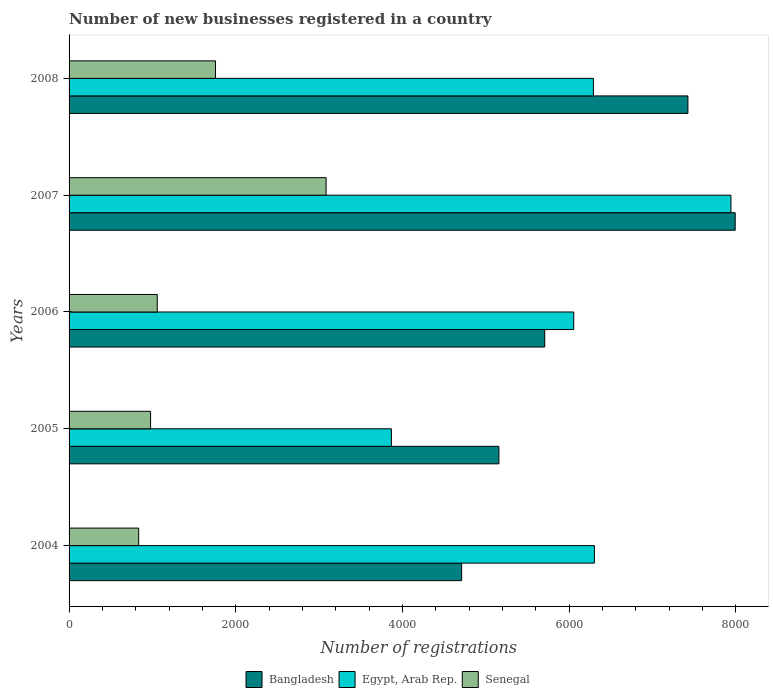How many different coloured bars are there?
Your answer should be very brief. 3. Are the number of bars per tick equal to the number of legend labels?
Ensure brevity in your answer.  Yes. Are the number of bars on each tick of the Y-axis equal?
Provide a short and direct response. Yes. How many bars are there on the 4th tick from the top?
Your answer should be very brief. 3. What is the label of the 4th group of bars from the top?
Provide a succinct answer. 2005. What is the number of new businesses registered in Senegal in 2006?
Your answer should be compact. 1058. Across all years, what is the maximum number of new businesses registered in Senegal?
Give a very brief answer. 3084. Across all years, what is the minimum number of new businesses registered in Senegal?
Your answer should be compact. 835. In which year was the number of new businesses registered in Egypt, Arab Rep. maximum?
Provide a succinct answer. 2007. In which year was the number of new businesses registered in Egypt, Arab Rep. minimum?
Your response must be concise. 2005. What is the total number of new businesses registered in Bangladesh in the graph?
Provide a succinct answer. 3.10e+04. What is the difference between the number of new businesses registered in Senegal in 2007 and that in 2008?
Offer a very short reply. 1327. What is the difference between the number of new businesses registered in Egypt, Arab Rep. in 2005 and the number of new businesses registered in Senegal in 2008?
Provide a succinct answer. 2110. What is the average number of new businesses registered in Senegal per year?
Offer a terse response. 1542.4. In the year 2005, what is the difference between the number of new businesses registered in Egypt, Arab Rep. and number of new businesses registered in Bangladesh?
Your answer should be very brief. -1290. What is the ratio of the number of new businesses registered in Bangladesh in 2004 to that in 2008?
Ensure brevity in your answer.  0.63. Is the number of new businesses registered in Bangladesh in 2005 less than that in 2007?
Make the answer very short. Yes. Is the difference between the number of new businesses registered in Egypt, Arab Rep. in 2005 and 2006 greater than the difference between the number of new businesses registered in Bangladesh in 2005 and 2006?
Keep it short and to the point. No. What is the difference between the highest and the second highest number of new businesses registered in Egypt, Arab Rep.?
Your answer should be compact. 1638. What is the difference between the highest and the lowest number of new businesses registered in Senegal?
Your answer should be very brief. 2249. In how many years, is the number of new businesses registered in Bangladesh greater than the average number of new businesses registered in Bangladesh taken over all years?
Your answer should be compact. 2. What does the 3rd bar from the top in 2006 represents?
Ensure brevity in your answer.  Bangladesh. What does the 2nd bar from the bottom in 2004 represents?
Your answer should be compact. Egypt, Arab Rep. Is it the case that in every year, the sum of the number of new businesses registered in Senegal and number of new businesses registered in Bangladesh is greater than the number of new businesses registered in Egypt, Arab Rep.?
Offer a very short reply. No. How many bars are there?
Provide a succinct answer. 15. Are all the bars in the graph horizontal?
Your response must be concise. Yes. Are the values on the major ticks of X-axis written in scientific E-notation?
Your answer should be very brief. No. Does the graph contain any zero values?
Your answer should be compact. No. Does the graph contain grids?
Provide a short and direct response. No. How many legend labels are there?
Give a very brief answer. 3. How are the legend labels stacked?
Keep it short and to the point. Horizontal. What is the title of the graph?
Offer a very short reply. Number of new businesses registered in a country. Does "Mali" appear as one of the legend labels in the graph?
Provide a succinct answer. No. What is the label or title of the X-axis?
Your answer should be compact. Number of registrations. What is the Number of registrations of Bangladesh in 2004?
Offer a very short reply. 4710. What is the Number of registrations in Egypt, Arab Rep. in 2004?
Provide a succinct answer. 6303. What is the Number of registrations of Senegal in 2004?
Keep it short and to the point. 835. What is the Number of registrations in Bangladesh in 2005?
Your response must be concise. 5157. What is the Number of registrations of Egypt, Arab Rep. in 2005?
Your response must be concise. 3867. What is the Number of registrations of Senegal in 2005?
Offer a very short reply. 978. What is the Number of registrations in Bangladesh in 2006?
Your response must be concise. 5707. What is the Number of registrations in Egypt, Arab Rep. in 2006?
Provide a succinct answer. 6055. What is the Number of registrations in Senegal in 2006?
Provide a short and direct response. 1058. What is the Number of registrations in Bangladesh in 2007?
Offer a very short reply. 7992. What is the Number of registrations in Egypt, Arab Rep. in 2007?
Make the answer very short. 7941. What is the Number of registrations of Senegal in 2007?
Make the answer very short. 3084. What is the Number of registrations of Bangladesh in 2008?
Your response must be concise. 7425. What is the Number of registrations in Egypt, Arab Rep. in 2008?
Your response must be concise. 6291. What is the Number of registrations of Senegal in 2008?
Provide a short and direct response. 1757. Across all years, what is the maximum Number of registrations of Bangladesh?
Offer a terse response. 7992. Across all years, what is the maximum Number of registrations in Egypt, Arab Rep.?
Offer a terse response. 7941. Across all years, what is the maximum Number of registrations of Senegal?
Your response must be concise. 3084. Across all years, what is the minimum Number of registrations in Bangladesh?
Your response must be concise. 4710. Across all years, what is the minimum Number of registrations in Egypt, Arab Rep.?
Ensure brevity in your answer.  3867. Across all years, what is the minimum Number of registrations in Senegal?
Make the answer very short. 835. What is the total Number of registrations in Bangladesh in the graph?
Keep it short and to the point. 3.10e+04. What is the total Number of registrations of Egypt, Arab Rep. in the graph?
Give a very brief answer. 3.05e+04. What is the total Number of registrations in Senegal in the graph?
Your response must be concise. 7712. What is the difference between the Number of registrations in Bangladesh in 2004 and that in 2005?
Provide a short and direct response. -447. What is the difference between the Number of registrations in Egypt, Arab Rep. in 2004 and that in 2005?
Offer a terse response. 2436. What is the difference between the Number of registrations of Senegal in 2004 and that in 2005?
Your answer should be very brief. -143. What is the difference between the Number of registrations in Bangladesh in 2004 and that in 2006?
Make the answer very short. -997. What is the difference between the Number of registrations of Egypt, Arab Rep. in 2004 and that in 2006?
Provide a short and direct response. 248. What is the difference between the Number of registrations in Senegal in 2004 and that in 2006?
Your answer should be very brief. -223. What is the difference between the Number of registrations in Bangladesh in 2004 and that in 2007?
Offer a very short reply. -3282. What is the difference between the Number of registrations of Egypt, Arab Rep. in 2004 and that in 2007?
Provide a succinct answer. -1638. What is the difference between the Number of registrations of Senegal in 2004 and that in 2007?
Your answer should be very brief. -2249. What is the difference between the Number of registrations in Bangladesh in 2004 and that in 2008?
Ensure brevity in your answer.  -2715. What is the difference between the Number of registrations of Senegal in 2004 and that in 2008?
Ensure brevity in your answer.  -922. What is the difference between the Number of registrations in Bangladesh in 2005 and that in 2006?
Offer a terse response. -550. What is the difference between the Number of registrations of Egypt, Arab Rep. in 2005 and that in 2006?
Give a very brief answer. -2188. What is the difference between the Number of registrations in Senegal in 2005 and that in 2006?
Ensure brevity in your answer.  -80. What is the difference between the Number of registrations of Bangladesh in 2005 and that in 2007?
Offer a terse response. -2835. What is the difference between the Number of registrations of Egypt, Arab Rep. in 2005 and that in 2007?
Keep it short and to the point. -4074. What is the difference between the Number of registrations of Senegal in 2005 and that in 2007?
Your answer should be very brief. -2106. What is the difference between the Number of registrations in Bangladesh in 2005 and that in 2008?
Keep it short and to the point. -2268. What is the difference between the Number of registrations in Egypt, Arab Rep. in 2005 and that in 2008?
Provide a succinct answer. -2424. What is the difference between the Number of registrations of Senegal in 2005 and that in 2008?
Make the answer very short. -779. What is the difference between the Number of registrations of Bangladesh in 2006 and that in 2007?
Offer a very short reply. -2285. What is the difference between the Number of registrations of Egypt, Arab Rep. in 2006 and that in 2007?
Make the answer very short. -1886. What is the difference between the Number of registrations in Senegal in 2006 and that in 2007?
Ensure brevity in your answer.  -2026. What is the difference between the Number of registrations in Bangladesh in 2006 and that in 2008?
Provide a short and direct response. -1718. What is the difference between the Number of registrations in Egypt, Arab Rep. in 2006 and that in 2008?
Provide a succinct answer. -236. What is the difference between the Number of registrations in Senegal in 2006 and that in 2008?
Ensure brevity in your answer.  -699. What is the difference between the Number of registrations in Bangladesh in 2007 and that in 2008?
Provide a short and direct response. 567. What is the difference between the Number of registrations in Egypt, Arab Rep. in 2007 and that in 2008?
Your answer should be compact. 1650. What is the difference between the Number of registrations of Senegal in 2007 and that in 2008?
Your response must be concise. 1327. What is the difference between the Number of registrations in Bangladesh in 2004 and the Number of registrations in Egypt, Arab Rep. in 2005?
Your answer should be very brief. 843. What is the difference between the Number of registrations of Bangladesh in 2004 and the Number of registrations of Senegal in 2005?
Your answer should be compact. 3732. What is the difference between the Number of registrations in Egypt, Arab Rep. in 2004 and the Number of registrations in Senegal in 2005?
Ensure brevity in your answer.  5325. What is the difference between the Number of registrations of Bangladesh in 2004 and the Number of registrations of Egypt, Arab Rep. in 2006?
Ensure brevity in your answer.  -1345. What is the difference between the Number of registrations in Bangladesh in 2004 and the Number of registrations in Senegal in 2006?
Keep it short and to the point. 3652. What is the difference between the Number of registrations in Egypt, Arab Rep. in 2004 and the Number of registrations in Senegal in 2006?
Provide a succinct answer. 5245. What is the difference between the Number of registrations in Bangladesh in 2004 and the Number of registrations in Egypt, Arab Rep. in 2007?
Ensure brevity in your answer.  -3231. What is the difference between the Number of registrations in Bangladesh in 2004 and the Number of registrations in Senegal in 2007?
Provide a short and direct response. 1626. What is the difference between the Number of registrations of Egypt, Arab Rep. in 2004 and the Number of registrations of Senegal in 2007?
Provide a succinct answer. 3219. What is the difference between the Number of registrations of Bangladesh in 2004 and the Number of registrations of Egypt, Arab Rep. in 2008?
Give a very brief answer. -1581. What is the difference between the Number of registrations of Bangladesh in 2004 and the Number of registrations of Senegal in 2008?
Offer a terse response. 2953. What is the difference between the Number of registrations of Egypt, Arab Rep. in 2004 and the Number of registrations of Senegal in 2008?
Provide a short and direct response. 4546. What is the difference between the Number of registrations in Bangladesh in 2005 and the Number of registrations in Egypt, Arab Rep. in 2006?
Keep it short and to the point. -898. What is the difference between the Number of registrations of Bangladesh in 2005 and the Number of registrations of Senegal in 2006?
Your answer should be compact. 4099. What is the difference between the Number of registrations in Egypt, Arab Rep. in 2005 and the Number of registrations in Senegal in 2006?
Your response must be concise. 2809. What is the difference between the Number of registrations in Bangladesh in 2005 and the Number of registrations in Egypt, Arab Rep. in 2007?
Ensure brevity in your answer.  -2784. What is the difference between the Number of registrations of Bangladesh in 2005 and the Number of registrations of Senegal in 2007?
Ensure brevity in your answer.  2073. What is the difference between the Number of registrations in Egypt, Arab Rep. in 2005 and the Number of registrations in Senegal in 2007?
Ensure brevity in your answer.  783. What is the difference between the Number of registrations in Bangladesh in 2005 and the Number of registrations in Egypt, Arab Rep. in 2008?
Offer a terse response. -1134. What is the difference between the Number of registrations in Bangladesh in 2005 and the Number of registrations in Senegal in 2008?
Provide a succinct answer. 3400. What is the difference between the Number of registrations in Egypt, Arab Rep. in 2005 and the Number of registrations in Senegal in 2008?
Keep it short and to the point. 2110. What is the difference between the Number of registrations in Bangladesh in 2006 and the Number of registrations in Egypt, Arab Rep. in 2007?
Your answer should be compact. -2234. What is the difference between the Number of registrations of Bangladesh in 2006 and the Number of registrations of Senegal in 2007?
Keep it short and to the point. 2623. What is the difference between the Number of registrations in Egypt, Arab Rep. in 2006 and the Number of registrations in Senegal in 2007?
Ensure brevity in your answer.  2971. What is the difference between the Number of registrations of Bangladesh in 2006 and the Number of registrations of Egypt, Arab Rep. in 2008?
Make the answer very short. -584. What is the difference between the Number of registrations of Bangladesh in 2006 and the Number of registrations of Senegal in 2008?
Your answer should be very brief. 3950. What is the difference between the Number of registrations in Egypt, Arab Rep. in 2006 and the Number of registrations in Senegal in 2008?
Provide a succinct answer. 4298. What is the difference between the Number of registrations of Bangladesh in 2007 and the Number of registrations of Egypt, Arab Rep. in 2008?
Provide a short and direct response. 1701. What is the difference between the Number of registrations in Bangladesh in 2007 and the Number of registrations in Senegal in 2008?
Ensure brevity in your answer.  6235. What is the difference between the Number of registrations in Egypt, Arab Rep. in 2007 and the Number of registrations in Senegal in 2008?
Your response must be concise. 6184. What is the average Number of registrations in Bangladesh per year?
Offer a terse response. 6198.2. What is the average Number of registrations in Egypt, Arab Rep. per year?
Provide a succinct answer. 6091.4. What is the average Number of registrations in Senegal per year?
Offer a terse response. 1542.4. In the year 2004, what is the difference between the Number of registrations of Bangladesh and Number of registrations of Egypt, Arab Rep.?
Keep it short and to the point. -1593. In the year 2004, what is the difference between the Number of registrations of Bangladesh and Number of registrations of Senegal?
Your response must be concise. 3875. In the year 2004, what is the difference between the Number of registrations of Egypt, Arab Rep. and Number of registrations of Senegal?
Your answer should be very brief. 5468. In the year 2005, what is the difference between the Number of registrations in Bangladesh and Number of registrations in Egypt, Arab Rep.?
Give a very brief answer. 1290. In the year 2005, what is the difference between the Number of registrations in Bangladesh and Number of registrations in Senegal?
Give a very brief answer. 4179. In the year 2005, what is the difference between the Number of registrations in Egypt, Arab Rep. and Number of registrations in Senegal?
Offer a very short reply. 2889. In the year 2006, what is the difference between the Number of registrations in Bangladesh and Number of registrations in Egypt, Arab Rep.?
Give a very brief answer. -348. In the year 2006, what is the difference between the Number of registrations of Bangladesh and Number of registrations of Senegal?
Keep it short and to the point. 4649. In the year 2006, what is the difference between the Number of registrations of Egypt, Arab Rep. and Number of registrations of Senegal?
Your response must be concise. 4997. In the year 2007, what is the difference between the Number of registrations of Bangladesh and Number of registrations of Egypt, Arab Rep.?
Your response must be concise. 51. In the year 2007, what is the difference between the Number of registrations in Bangladesh and Number of registrations in Senegal?
Keep it short and to the point. 4908. In the year 2007, what is the difference between the Number of registrations in Egypt, Arab Rep. and Number of registrations in Senegal?
Your response must be concise. 4857. In the year 2008, what is the difference between the Number of registrations in Bangladesh and Number of registrations in Egypt, Arab Rep.?
Keep it short and to the point. 1134. In the year 2008, what is the difference between the Number of registrations of Bangladesh and Number of registrations of Senegal?
Provide a succinct answer. 5668. In the year 2008, what is the difference between the Number of registrations in Egypt, Arab Rep. and Number of registrations in Senegal?
Offer a very short reply. 4534. What is the ratio of the Number of registrations in Bangladesh in 2004 to that in 2005?
Give a very brief answer. 0.91. What is the ratio of the Number of registrations in Egypt, Arab Rep. in 2004 to that in 2005?
Keep it short and to the point. 1.63. What is the ratio of the Number of registrations of Senegal in 2004 to that in 2005?
Provide a succinct answer. 0.85. What is the ratio of the Number of registrations of Bangladesh in 2004 to that in 2006?
Give a very brief answer. 0.83. What is the ratio of the Number of registrations of Egypt, Arab Rep. in 2004 to that in 2006?
Offer a terse response. 1.04. What is the ratio of the Number of registrations in Senegal in 2004 to that in 2006?
Your answer should be compact. 0.79. What is the ratio of the Number of registrations in Bangladesh in 2004 to that in 2007?
Ensure brevity in your answer.  0.59. What is the ratio of the Number of registrations of Egypt, Arab Rep. in 2004 to that in 2007?
Give a very brief answer. 0.79. What is the ratio of the Number of registrations of Senegal in 2004 to that in 2007?
Your answer should be compact. 0.27. What is the ratio of the Number of registrations in Bangladesh in 2004 to that in 2008?
Make the answer very short. 0.63. What is the ratio of the Number of registrations in Egypt, Arab Rep. in 2004 to that in 2008?
Offer a very short reply. 1. What is the ratio of the Number of registrations in Senegal in 2004 to that in 2008?
Your answer should be very brief. 0.48. What is the ratio of the Number of registrations of Bangladesh in 2005 to that in 2006?
Keep it short and to the point. 0.9. What is the ratio of the Number of registrations in Egypt, Arab Rep. in 2005 to that in 2006?
Provide a short and direct response. 0.64. What is the ratio of the Number of registrations in Senegal in 2005 to that in 2006?
Keep it short and to the point. 0.92. What is the ratio of the Number of registrations in Bangladesh in 2005 to that in 2007?
Offer a terse response. 0.65. What is the ratio of the Number of registrations of Egypt, Arab Rep. in 2005 to that in 2007?
Ensure brevity in your answer.  0.49. What is the ratio of the Number of registrations in Senegal in 2005 to that in 2007?
Your answer should be very brief. 0.32. What is the ratio of the Number of registrations in Bangladesh in 2005 to that in 2008?
Keep it short and to the point. 0.69. What is the ratio of the Number of registrations of Egypt, Arab Rep. in 2005 to that in 2008?
Offer a very short reply. 0.61. What is the ratio of the Number of registrations in Senegal in 2005 to that in 2008?
Ensure brevity in your answer.  0.56. What is the ratio of the Number of registrations in Bangladesh in 2006 to that in 2007?
Give a very brief answer. 0.71. What is the ratio of the Number of registrations of Egypt, Arab Rep. in 2006 to that in 2007?
Give a very brief answer. 0.76. What is the ratio of the Number of registrations in Senegal in 2006 to that in 2007?
Offer a very short reply. 0.34. What is the ratio of the Number of registrations of Bangladesh in 2006 to that in 2008?
Offer a very short reply. 0.77. What is the ratio of the Number of registrations of Egypt, Arab Rep. in 2006 to that in 2008?
Offer a very short reply. 0.96. What is the ratio of the Number of registrations of Senegal in 2006 to that in 2008?
Provide a succinct answer. 0.6. What is the ratio of the Number of registrations of Bangladesh in 2007 to that in 2008?
Your response must be concise. 1.08. What is the ratio of the Number of registrations of Egypt, Arab Rep. in 2007 to that in 2008?
Your response must be concise. 1.26. What is the ratio of the Number of registrations of Senegal in 2007 to that in 2008?
Your answer should be compact. 1.76. What is the difference between the highest and the second highest Number of registrations in Bangladesh?
Offer a terse response. 567. What is the difference between the highest and the second highest Number of registrations of Egypt, Arab Rep.?
Provide a succinct answer. 1638. What is the difference between the highest and the second highest Number of registrations of Senegal?
Provide a short and direct response. 1327. What is the difference between the highest and the lowest Number of registrations in Bangladesh?
Offer a very short reply. 3282. What is the difference between the highest and the lowest Number of registrations of Egypt, Arab Rep.?
Give a very brief answer. 4074. What is the difference between the highest and the lowest Number of registrations of Senegal?
Your answer should be very brief. 2249. 